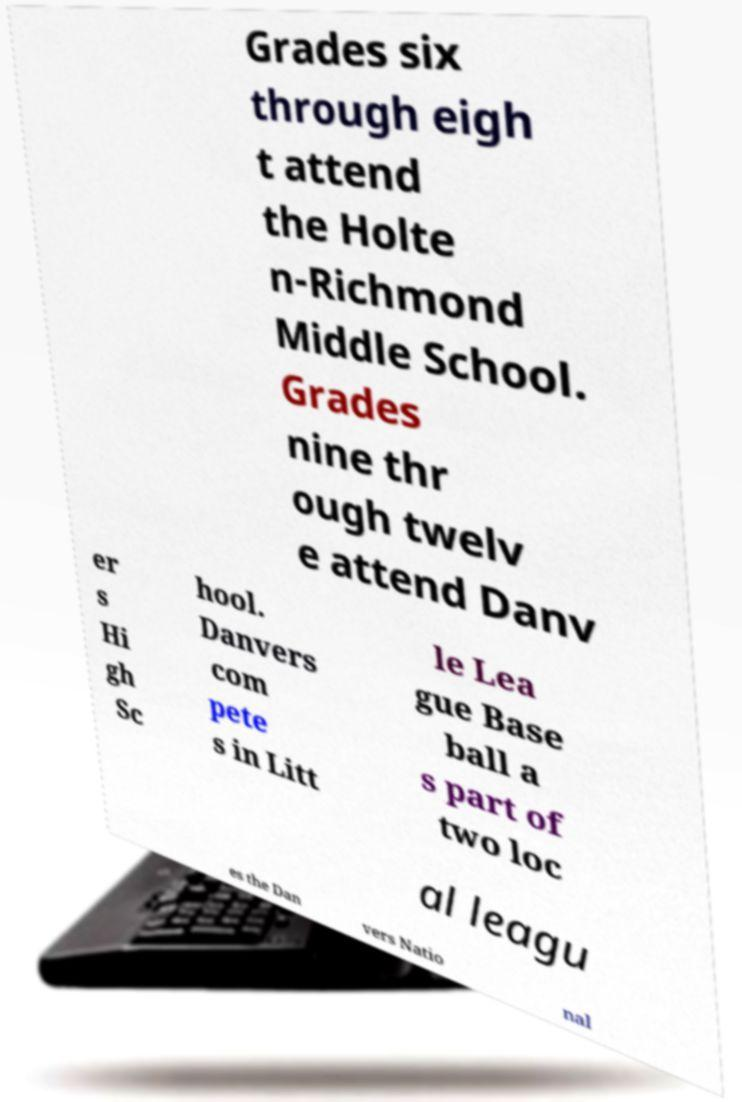I need the written content from this picture converted into text. Can you do that? Grades six through eigh t attend the Holte n-Richmond Middle School. Grades nine thr ough twelv e attend Danv er s Hi gh Sc hool. Danvers com pete s in Litt le Lea gue Base ball a s part of two loc al leagu es the Dan vers Natio nal 